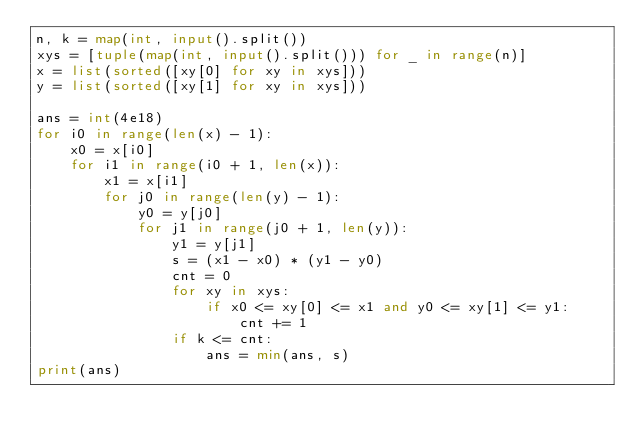<code> <loc_0><loc_0><loc_500><loc_500><_Python_>n, k = map(int, input().split())
xys = [tuple(map(int, input().split())) for _ in range(n)]
x = list(sorted([xy[0] for xy in xys]))
y = list(sorted([xy[1] for xy in xys]))

ans = int(4e18)
for i0 in range(len(x) - 1):
    x0 = x[i0]
    for i1 in range(i0 + 1, len(x)):
        x1 = x[i1]
        for j0 in range(len(y) - 1):
            y0 = y[j0]
            for j1 in range(j0 + 1, len(y)):
                y1 = y[j1]
                s = (x1 - x0) * (y1 - y0)
                cnt = 0
                for xy in xys:
                    if x0 <= xy[0] <= x1 and y0 <= xy[1] <= y1:
                        cnt += 1
                if k <= cnt:
                    ans = min(ans, s)
print(ans)</code> 